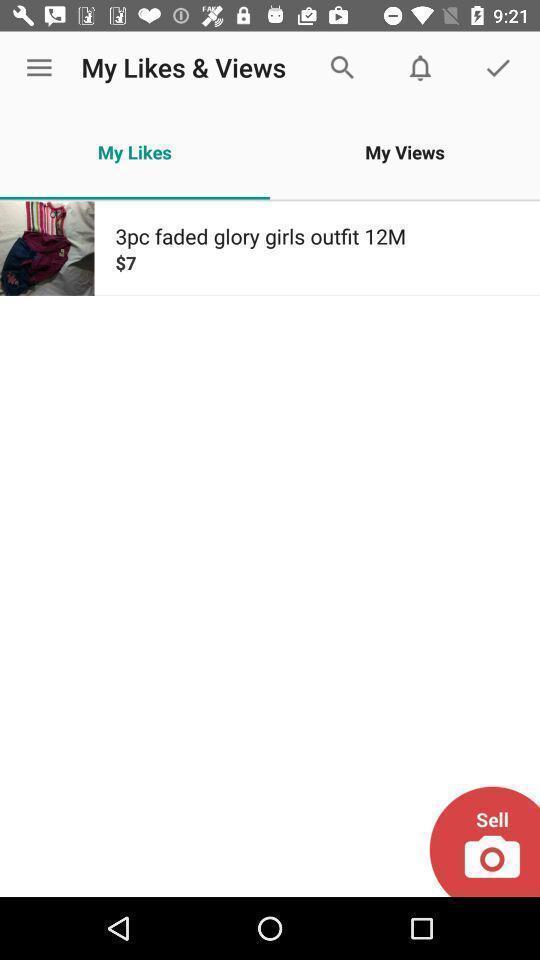Summarize the information in this screenshot. Screen showing my likes. 